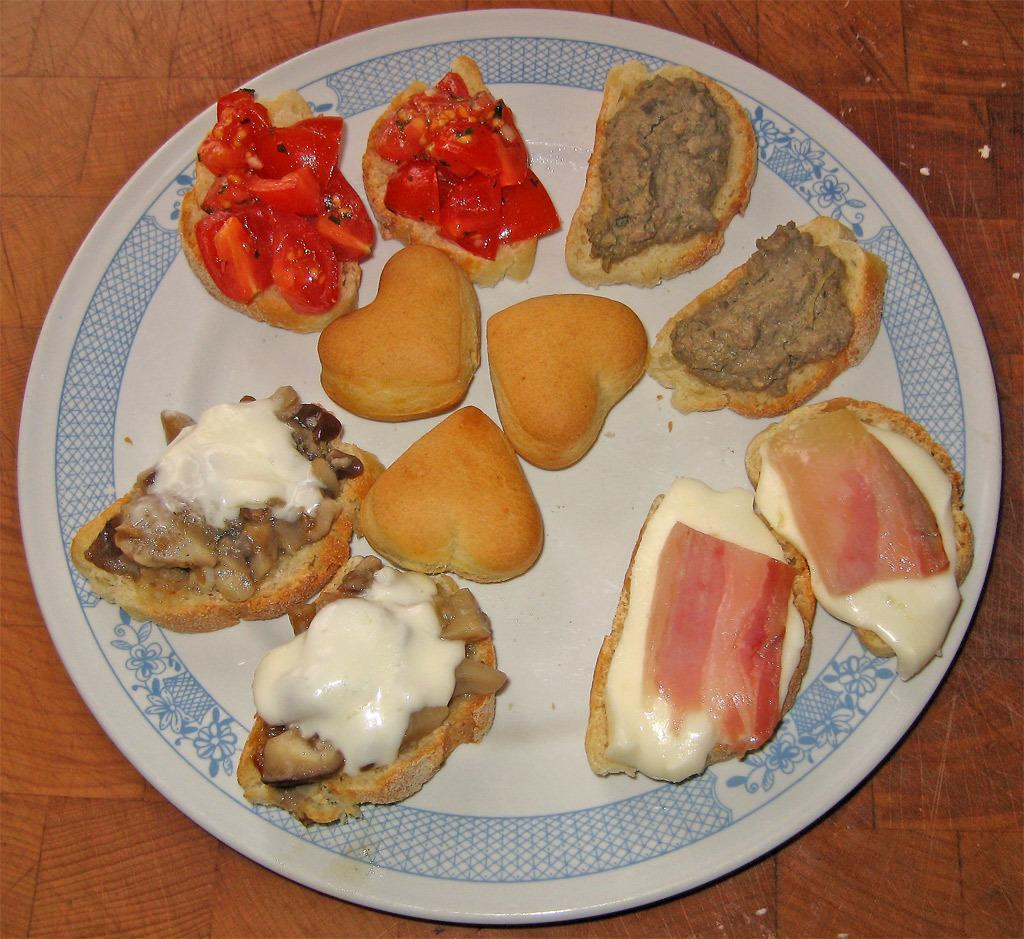What type of food is on the plate in the image? There is food on the plate, with cheese, meat, and veggies present. How is the food arranged on the plate? The food is on bread in the image. Where is the plate located? The plate is on a table. What grade did the pet receive on its report card in the image? There is no pet or report card present in the image. How many buttons are on the shirt of the person in the image? There is no person or shirt visible in the image. 